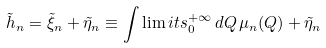Convert formula to latex. <formula><loc_0><loc_0><loc_500><loc_500>\tilde { h } _ { n } = \tilde { \xi } _ { n } + \tilde { \eta } _ { n } \equiv \int \lim i t s _ { 0 } ^ { + \infty } \, d Q \, \mu _ { n } ( Q ) + \tilde { \eta } _ { n }</formula> 